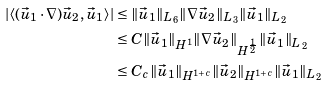Convert formula to latex. <formula><loc_0><loc_0><loc_500><loc_500>| \langle ( \vec { u } _ { 1 } \cdot \nabla ) \vec { u } _ { 2 } , \vec { u } _ { 1 } \rangle | & \leq \| \vec { u } _ { 1 } \| _ { L _ { 6 } } \| \nabla \vec { u } _ { 2 } \| _ { L _ { 3 } } \| \vec { u } _ { 1 } \| _ { L _ { 2 } } \\ & \leq C \| \vec { u } _ { 1 } \| _ { H ^ { 1 } } \| \nabla \vec { u } _ { 2 } \| _ { H ^ { \frac { 1 } { 2 } } } \| \vec { u } _ { 1 } \| _ { L _ { 2 } } \\ & \leq C _ { c } \| \vec { u } _ { 1 } \| _ { H ^ { 1 + c } } \| \vec { u } _ { 2 } \| _ { H ^ { 1 + c } } \| \vec { u } _ { 1 } \| _ { L _ { 2 } }</formula> 